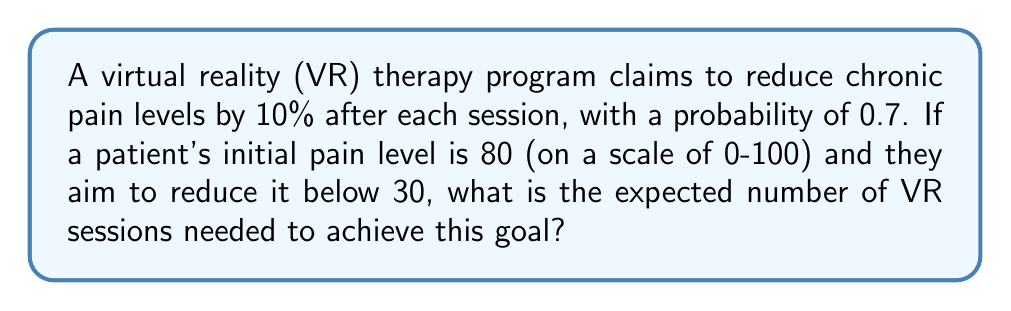Show me your answer to this math problem. Let's approach this step-by-step:

1) First, we need to calculate how many successful sessions are required to reduce the pain from 80 to below 30.

   Let $x$ be the number of successful sessions.
   $80 \cdot (0.9)^x < 30$

2) Solving for $x$:
   $$(0.9)^x < \frac{30}{80} = 0.375$$
   $$x \cdot \log(0.9) < \log(0.375)$$
   $$x > \frac{\log(0.375)}{\log(0.9)} \approx 8.76$$

   Therefore, 9 successful sessions are needed.

3) Now, we need to find the expected number of trials needed to get 9 successes in a Negative Binomial distribution.

4) The probability of success for each session is 0.7.

5) The expected number of trials in a Negative Binomial distribution is given by:

   $$E[X] = \frac{r}{p}$$

   Where $r$ is the number of successes needed and $p$ is the probability of success.

6) Substituting our values:

   $$E[X] = \frac{9}{0.7} = \frac{90}{7} \approx 12.86$$

Therefore, the expected number of VR sessions needed is approximately 12.86.
Answer: $\frac{90}{7}$ or approximately 12.86 sessions 